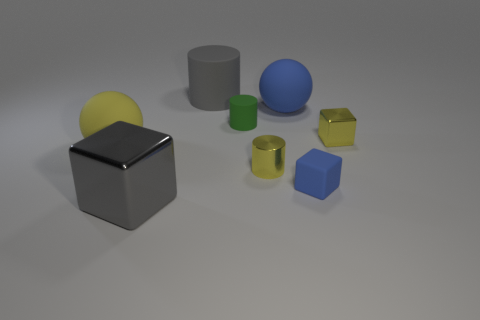There is a large cube; does it have the same color as the cylinder that is behind the tiny green matte cylinder?
Offer a very short reply. Yes. Is there another small green object of the same shape as the small green object?
Your answer should be very brief. No. Is the shape of the object that is on the left side of the gray metal block the same as the matte object in front of the big yellow sphere?
Ensure brevity in your answer.  No. How many things are either tiny green shiny balls or rubber objects?
Offer a terse response. 5. There is a gray metal thing that is the same shape as the tiny blue thing; what is its size?
Offer a terse response. Large. Is the number of small blue cubes behind the blue sphere greater than the number of big red rubber blocks?
Provide a short and direct response. No. Does the large blue thing have the same material as the green cylinder?
Your response must be concise. Yes. How many objects are large things that are to the right of the big gray cube or objects to the right of the blue rubber sphere?
Your response must be concise. 4. What color is the big metal object that is the same shape as the small blue matte thing?
Your answer should be very brief. Gray. How many small metallic objects are the same color as the big shiny cube?
Keep it short and to the point. 0. 